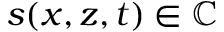<formula> <loc_0><loc_0><loc_500><loc_500>s ( x , z , t ) \in \mathbb { C }</formula> 